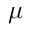<formula> <loc_0><loc_0><loc_500><loc_500>\mu</formula> 